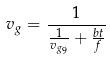<formula> <loc_0><loc_0><loc_500><loc_500>v _ { g } = \frac { 1 } { \frac { 1 } { v _ { g _ { 9 } } } + \frac { b t } { f } }</formula> 